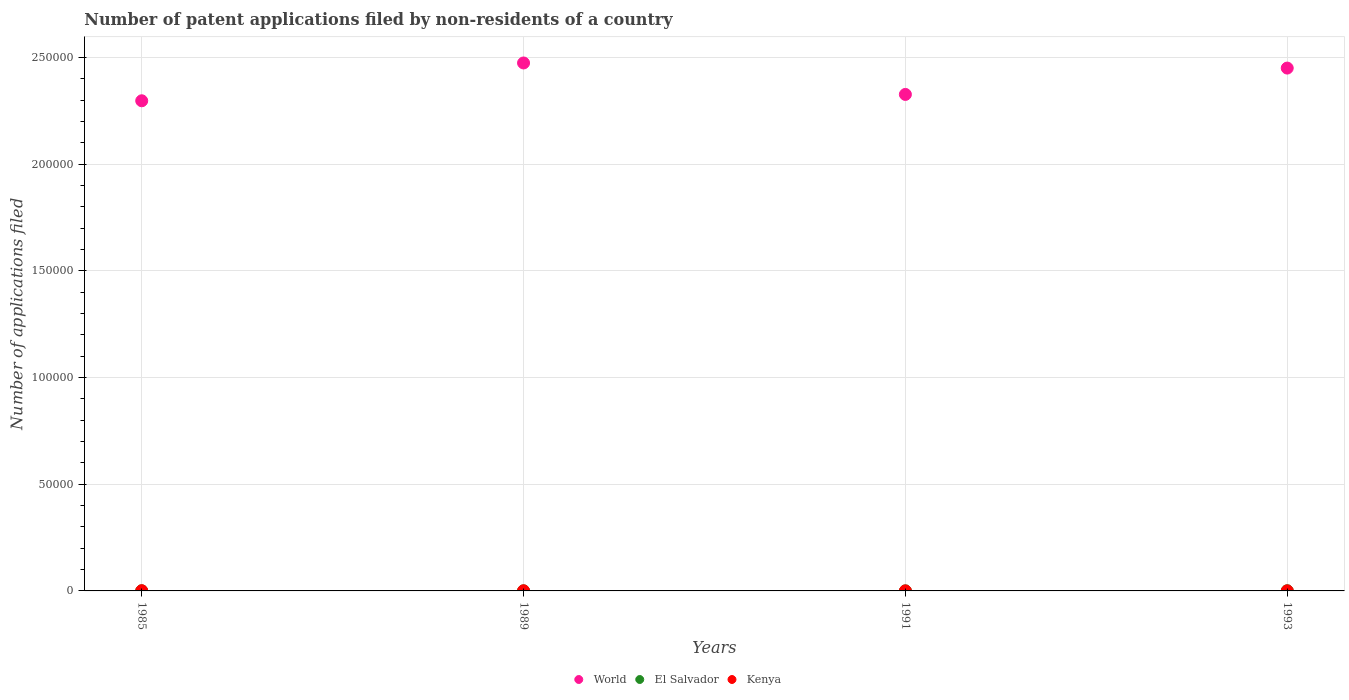Is the number of dotlines equal to the number of legend labels?
Keep it short and to the point. Yes. Across all years, what is the maximum number of applications filed in Kenya?
Ensure brevity in your answer.  98. Across all years, what is the minimum number of applications filed in World?
Offer a terse response. 2.30e+05. In which year was the number of applications filed in World minimum?
Your answer should be very brief. 1985. What is the total number of applications filed in El Salvador in the graph?
Your response must be concise. 175. What is the average number of applications filed in El Salvador per year?
Provide a short and direct response. 43.75. In the year 1989, what is the difference between the number of applications filed in El Salvador and number of applications filed in Kenya?
Your answer should be very brief. -31. What is the ratio of the number of applications filed in Kenya in 1991 to that in 1993?
Your response must be concise. 0.54. Is the number of applications filed in Kenya in 1985 less than that in 1993?
Your response must be concise. No. What is the difference between the highest and the second highest number of applications filed in World?
Offer a terse response. 2395. What is the difference between the highest and the lowest number of applications filed in Kenya?
Provide a short and direct response. 78. In how many years, is the number of applications filed in Kenya greater than the average number of applications filed in Kenya taken over all years?
Make the answer very short. 2. Is the sum of the number of applications filed in El Salvador in 1985 and 1991 greater than the maximum number of applications filed in World across all years?
Offer a terse response. No. Does the number of applications filed in Kenya monotonically increase over the years?
Offer a very short reply. No. How many dotlines are there?
Give a very brief answer. 3. How many years are there in the graph?
Your answer should be very brief. 4. Are the values on the major ticks of Y-axis written in scientific E-notation?
Offer a terse response. No. Does the graph contain any zero values?
Ensure brevity in your answer.  No. Does the graph contain grids?
Ensure brevity in your answer.  Yes. What is the title of the graph?
Your answer should be very brief. Number of patent applications filed by non-residents of a country. Does "Afghanistan" appear as one of the legend labels in the graph?
Provide a succinct answer. No. What is the label or title of the Y-axis?
Give a very brief answer. Number of applications filed. What is the Number of applications filed of World in 1985?
Make the answer very short. 2.30e+05. What is the Number of applications filed of Kenya in 1985?
Offer a very short reply. 98. What is the Number of applications filed in World in 1989?
Provide a short and direct response. 2.47e+05. What is the Number of applications filed in El Salvador in 1989?
Your response must be concise. 34. What is the Number of applications filed of World in 1991?
Your answer should be compact. 2.33e+05. What is the Number of applications filed of Kenya in 1991?
Give a very brief answer. 20. What is the Number of applications filed of World in 1993?
Offer a terse response. 2.45e+05. Across all years, what is the maximum Number of applications filed of World?
Provide a succinct answer. 2.47e+05. Across all years, what is the maximum Number of applications filed in El Salvador?
Provide a succinct answer. 75. Across all years, what is the minimum Number of applications filed in World?
Provide a succinct answer. 2.30e+05. What is the total Number of applications filed of World in the graph?
Provide a succinct answer. 9.55e+05. What is the total Number of applications filed in El Salvador in the graph?
Your answer should be compact. 175. What is the total Number of applications filed in Kenya in the graph?
Your answer should be very brief. 220. What is the difference between the Number of applications filed of World in 1985 and that in 1989?
Provide a succinct answer. -1.77e+04. What is the difference between the Number of applications filed in World in 1985 and that in 1991?
Make the answer very short. -2978. What is the difference between the Number of applications filed in El Salvador in 1985 and that in 1991?
Your response must be concise. 14. What is the difference between the Number of applications filed of World in 1985 and that in 1993?
Ensure brevity in your answer.  -1.53e+04. What is the difference between the Number of applications filed of El Salvador in 1985 and that in 1993?
Make the answer very short. -35. What is the difference between the Number of applications filed in Kenya in 1985 and that in 1993?
Your answer should be very brief. 61. What is the difference between the Number of applications filed in World in 1989 and that in 1991?
Your response must be concise. 1.47e+04. What is the difference between the Number of applications filed in El Salvador in 1989 and that in 1991?
Provide a succinct answer. 8. What is the difference between the Number of applications filed in Kenya in 1989 and that in 1991?
Ensure brevity in your answer.  45. What is the difference between the Number of applications filed in World in 1989 and that in 1993?
Give a very brief answer. 2395. What is the difference between the Number of applications filed in El Salvador in 1989 and that in 1993?
Your answer should be compact. -41. What is the difference between the Number of applications filed in Kenya in 1989 and that in 1993?
Make the answer very short. 28. What is the difference between the Number of applications filed of World in 1991 and that in 1993?
Offer a terse response. -1.23e+04. What is the difference between the Number of applications filed of El Salvador in 1991 and that in 1993?
Your answer should be compact. -49. What is the difference between the Number of applications filed of World in 1985 and the Number of applications filed of El Salvador in 1989?
Offer a very short reply. 2.30e+05. What is the difference between the Number of applications filed of World in 1985 and the Number of applications filed of Kenya in 1989?
Your response must be concise. 2.30e+05. What is the difference between the Number of applications filed in World in 1985 and the Number of applications filed in El Salvador in 1991?
Keep it short and to the point. 2.30e+05. What is the difference between the Number of applications filed in World in 1985 and the Number of applications filed in Kenya in 1991?
Make the answer very short. 2.30e+05. What is the difference between the Number of applications filed in World in 1985 and the Number of applications filed in El Salvador in 1993?
Ensure brevity in your answer.  2.30e+05. What is the difference between the Number of applications filed in World in 1985 and the Number of applications filed in Kenya in 1993?
Ensure brevity in your answer.  2.30e+05. What is the difference between the Number of applications filed in El Salvador in 1985 and the Number of applications filed in Kenya in 1993?
Offer a terse response. 3. What is the difference between the Number of applications filed of World in 1989 and the Number of applications filed of El Salvador in 1991?
Provide a short and direct response. 2.47e+05. What is the difference between the Number of applications filed in World in 1989 and the Number of applications filed in Kenya in 1991?
Provide a short and direct response. 2.47e+05. What is the difference between the Number of applications filed of El Salvador in 1989 and the Number of applications filed of Kenya in 1991?
Make the answer very short. 14. What is the difference between the Number of applications filed in World in 1989 and the Number of applications filed in El Salvador in 1993?
Offer a terse response. 2.47e+05. What is the difference between the Number of applications filed of World in 1989 and the Number of applications filed of Kenya in 1993?
Your response must be concise. 2.47e+05. What is the difference between the Number of applications filed in World in 1991 and the Number of applications filed in El Salvador in 1993?
Provide a succinct answer. 2.33e+05. What is the difference between the Number of applications filed of World in 1991 and the Number of applications filed of Kenya in 1993?
Offer a very short reply. 2.33e+05. What is the average Number of applications filed in World per year?
Ensure brevity in your answer.  2.39e+05. What is the average Number of applications filed of El Salvador per year?
Offer a terse response. 43.75. In the year 1985, what is the difference between the Number of applications filed of World and Number of applications filed of El Salvador?
Your response must be concise. 2.30e+05. In the year 1985, what is the difference between the Number of applications filed in World and Number of applications filed in Kenya?
Ensure brevity in your answer.  2.30e+05. In the year 1985, what is the difference between the Number of applications filed of El Salvador and Number of applications filed of Kenya?
Your response must be concise. -58. In the year 1989, what is the difference between the Number of applications filed of World and Number of applications filed of El Salvador?
Make the answer very short. 2.47e+05. In the year 1989, what is the difference between the Number of applications filed in World and Number of applications filed in Kenya?
Your response must be concise. 2.47e+05. In the year 1989, what is the difference between the Number of applications filed of El Salvador and Number of applications filed of Kenya?
Provide a succinct answer. -31. In the year 1991, what is the difference between the Number of applications filed in World and Number of applications filed in El Salvador?
Make the answer very short. 2.33e+05. In the year 1991, what is the difference between the Number of applications filed of World and Number of applications filed of Kenya?
Offer a very short reply. 2.33e+05. In the year 1991, what is the difference between the Number of applications filed in El Salvador and Number of applications filed in Kenya?
Ensure brevity in your answer.  6. In the year 1993, what is the difference between the Number of applications filed of World and Number of applications filed of El Salvador?
Ensure brevity in your answer.  2.45e+05. In the year 1993, what is the difference between the Number of applications filed of World and Number of applications filed of Kenya?
Your answer should be compact. 2.45e+05. What is the ratio of the Number of applications filed in World in 1985 to that in 1989?
Provide a short and direct response. 0.93. What is the ratio of the Number of applications filed of El Salvador in 1985 to that in 1989?
Make the answer very short. 1.18. What is the ratio of the Number of applications filed of Kenya in 1985 to that in 1989?
Give a very brief answer. 1.51. What is the ratio of the Number of applications filed in World in 1985 to that in 1991?
Your answer should be very brief. 0.99. What is the ratio of the Number of applications filed of El Salvador in 1985 to that in 1991?
Offer a very short reply. 1.54. What is the ratio of the Number of applications filed of World in 1985 to that in 1993?
Keep it short and to the point. 0.94. What is the ratio of the Number of applications filed in El Salvador in 1985 to that in 1993?
Make the answer very short. 0.53. What is the ratio of the Number of applications filed of Kenya in 1985 to that in 1993?
Your answer should be compact. 2.65. What is the ratio of the Number of applications filed in World in 1989 to that in 1991?
Ensure brevity in your answer.  1.06. What is the ratio of the Number of applications filed in El Salvador in 1989 to that in 1991?
Offer a very short reply. 1.31. What is the ratio of the Number of applications filed in Kenya in 1989 to that in 1991?
Offer a terse response. 3.25. What is the ratio of the Number of applications filed in World in 1989 to that in 1993?
Ensure brevity in your answer.  1.01. What is the ratio of the Number of applications filed of El Salvador in 1989 to that in 1993?
Your answer should be compact. 0.45. What is the ratio of the Number of applications filed of Kenya in 1989 to that in 1993?
Ensure brevity in your answer.  1.76. What is the ratio of the Number of applications filed in World in 1991 to that in 1993?
Provide a short and direct response. 0.95. What is the ratio of the Number of applications filed in El Salvador in 1991 to that in 1993?
Your response must be concise. 0.35. What is the ratio of the Number of applications filed in Kenya in 1991 to that in 1993?
Make the answer very short. 0.54. What is the difference between the highest and the second highest Number of applications filed of World?
Make the answer very short. 2395. What is the difference between the highest and the second highest Number of applications filed of El Salvador?
Keep it short and to the point. 35. What is the difference between the highest and the lowest Number of applications filed in World?
Offer a terse response. 1.77e+04. What is the difference between the highest and the lowest Number of applications filed of El Salvador?
Make the answer very short. 49. 